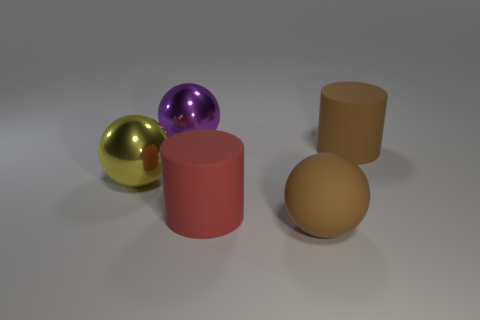Are the brown cylinder and the big yellow ball made of the same material?
Ensure brevity in your answer.  No. What number of objects are metallic balls on the left side of the purple ball or large purple shiny balls to the left of the big red matte thing?
Keep it short and to the point. 2. What is the color of the other rubber object that is the same shape as the red matte thing?
Your answer should be very brief. Brown. What number of rubber cylinders have the same color as the big rubber sphere?
Your response must be concise. 1. What number of things are brown matte things left of the large brown cylinder or red things?
Offer a terse response. 2. The large ball in front of the metallic sphere in front of the rubber thing that is behind the big red thing is what color?
Give a very brief answer. Brown. The thing that is made of the same material as the purple sphere is what color?
Offer a terse response. Yellow. How many large purple spheres are made of the same material as the big yellow object?
Provide a short and direct response. 1. Do the brown rubber thing behind the red thing and the purple shiny object have the same size?
Make the answer very short. Yes. The other cylinder that is the same size as the red matte cylinder is what color?
Provide a succinct answer. Brown. 